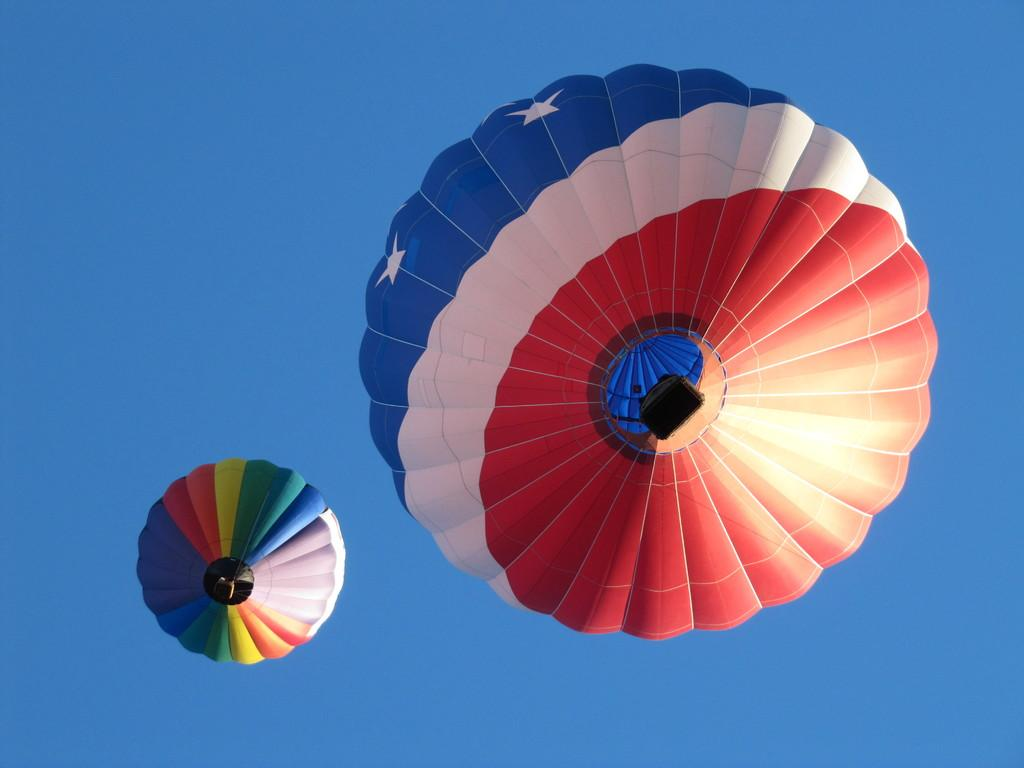What type of vehicles are in the image? There are hot air balloons in the image. Where are the hot air balloons located? The hot air balloons are in the sky. What type of tax is being discussed in the image? There is no discussion of tax in the image; it features hot air balloons in the sky. How many mice can be seen in the image? There are no mice present in the image. 